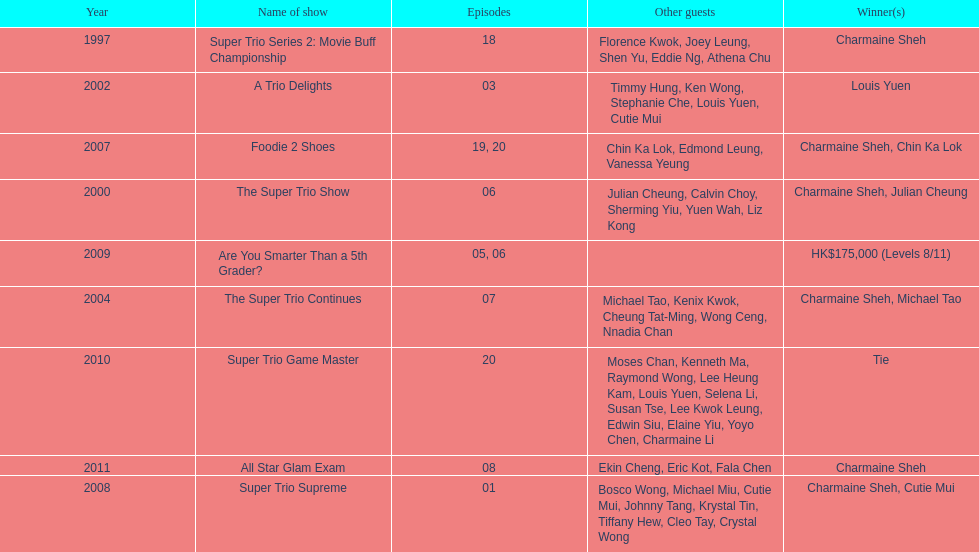What is the number of other guests in the 2002 show "a trio delights"? 5. 